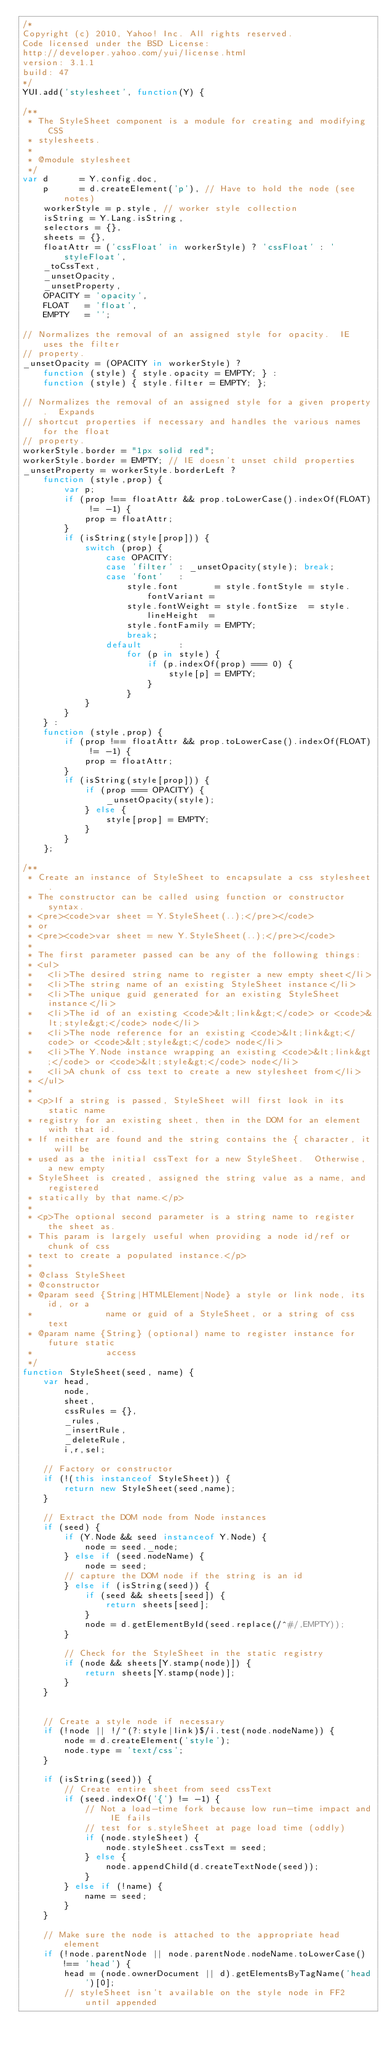Convert code to text. <code><loc_0><loc_0><loc_500><loc_500><_JavaScript_>/*
Copyright (c) 2010, Yahoo! Inc. All rights reserved.
Code licensed under the BSD License:
http://developer.yahoo.com/yui/license.html
version: 3.1.1
build: 47
*/
YUI.add('stylesheet', function(Y) {

/**
 * The StyleSheet component is a module for creating and modifying CSS
 * stylesheets.
 *
 * @module stylesheet
 */
var d      = Y.config.doc,
    p      = d.createElement('p'), // Have to hold the node (see notes)
    workerStyle = p.style, // worker style collection
    isString = Y.Lang.isString,
    selectors = {},
    sheets = {},
    floatAttr = ('cssFloat' in workerStyle) ? 'cssFloat' : 'styleFloat',
    _toCssText,
    _unsetOpacity,
    _unsetProperty,
    OPACITY = 'opacity',
    FLOAT   = 'float',
    EMPTY   = '';

// Normalizes the removal of an assigned style for opacity.  IE uses the filter
// property.
_unsetOpacity = (OPACITY in workerStyle) ?
    function (style) { style.opacity = EMPTY; } :
    function (style) { style.filter = EMPTY; };
        
// Normalizes the removal of an assigned style for a given property.  Expands
// shortcut properties if necessary and handles the various names for the float
// property.
workerStyle.border = "1px solid red";
workerStyle.border = EMPTY; // IE doesn't unset child properties
_unsetProperty = workerStyle.borderLeft ?
    function (style,prop) {
        var p;
        if (prop !== floatAttr && prop.toLowerCase().indexOf(FLOAT) != -1) {
            prop = floatAttr;
        }
        if (isString(style[prop])) {
            switch (prop) {
                case OPACITY:
                case 'filter' : _unsetOpacity(style); break;
                case 'font'   :
                    style.font       = style.fontStyle = style.fontVariant =
                    style.fontWeight = style.fontSize  = style.lineHeight  =
                    style.fontFamily = EMPTY;
                    break;
                default       :
                    for (p in style) {
                        if (p.indexOf(prop) === 0) {
                            style[p] = EMPTY;
                        }
                    }
            }
        }
    } :
    function (style,prop) {
        if (prop !== floatAttr && prop.toLowerCase().indexOf(FLOAT) != -1) {
            prop = floatAttr;
        }
        if (isString(style[prop])) {
            if (prop === OPACITY) {
                _unsetOpacity(style);
            } else {
                style[prop] = EMPTY;
            }
        }
    };
    
/**
 * Create an instance of StyleSheet to encapsulate a css stylesheet.
 * The constructor can be called using function or constructor syntax.
 * <pre><code>var sheet = Y.StyleSheet(..);</pre></code>
 * or
 * <pre><code>var sheet = new Y.StyleSheet(..);</pre></code>
 *
 * The first parameter passed can be any of the following things:
 * <ul>
 *   <li>The desired string name to register a new empty sheet</li>
 *   <li>The string name of an existing StyleSheet instance</li>
 *   <li>The unique guid generated for an existing StyleSheet instance</li>
 *   <li>The id of an existing <code>&lt;link&gt;</code> or <code>&lt;style&gt;</code> node</li>
 *   <li>The node reference for an existing <code>&lt;link&gt;</code> or <code>&lt;style&gt;</code> node</li>
 *   <li>The Y.Node instance wrapping an existing <code>&lt;link&gt;</code> or <code>&lt;style&gt;</code> node</li>
 *   <li>A chunk of css text to create a new stylesheet from</li>
 * </ul>
 *
 * <p>If a string is passed, StyleSheet will first look in its static name
 * registry for an existing sheet, then in the DOM for an element with that id.
 * If neither are found and the string contains the { character, it will be
 * used as a the initial cssText for a new StyleSheet.  Otherwise, a new empty
 * StyleSheet is created, assigned the string value as a name, and registered
 * statically by that name.</p>
 *
 * <p>The optional second parameter is a string name to register the sheet as.
 * This param is largely useful when providing a node id/ref or chunk of css
 * text to create a populated instance.</p>
 * 
 * @class StyleSheet
 * @constructor
 * @param seed {String|HTMLElement|Node} a style or link node, its id, or a
 *              name or guid of a StyleSheet, or a string of css text
 * @param name {String} (optional) name to register instance for future static
 *              access
 */
function StyleSheet(seed, name) {
    var head,
        node,
        sheet,
        cssRules = {},
        _rules,
        _insertRule,
        _deleteRule,
        i,r,sel;

    // Factory or constructor
    if (!(this instanceof StyleSheet)) {
        return new StyleSheet(seed,name);
    }

    // Extract the DOM node from Node instances
    if (seed) {
        if (Y.Node && seed instanceof Y.Node) {
            node = seed._node;
        } else if (seed.nodeName) {
            node = seed;
        // capture the DOM node if the string is an id
        } else if (isString(seed)) {
            if (seed && sheets[seed]) {
                return sheets[seed];
            }
            node = d.getElementById(seed.replace(/^#/,EMPTY));
        }

        // Check for the StyleSheet in the static registry
        if (node && sheets[Y.stamp(node)]) {
            return sheets[Y.stamp(node)];
        }
    }


    // Create a style node if necessary
    if (!node || !/^(?:style|link)$/i.test(node.nodeName)) {
        node = d.createElement('style');
        node.type = 'text/css';
    }

    if (isString(seed)) {
        // Create entire sheet from seed cssText
        if (seed.indexOf('{') != -1) {
            // Not a load-time fork because low run-time impact and IE fails
            // test for s.styleSheet at page load time (oddly)
            if (node.styleSheet) {
                node.styleSheet.cssText = seed;
            } else {
                node.appendChild(d.createTextNode(seed));
            }
        } else if (!name) {
            name = seed;
        }
    }

    // Make sure the node is attached to the appropriate head element
    if (!node.parentNode || node.parentNode.nodeName.toLowerCase() !== 'head') {
        head = (node.ownerDocument || d).getElementsByTagName('head')[0];
        // styleSheet isn't available on the style node in FF2 until appended</code> 